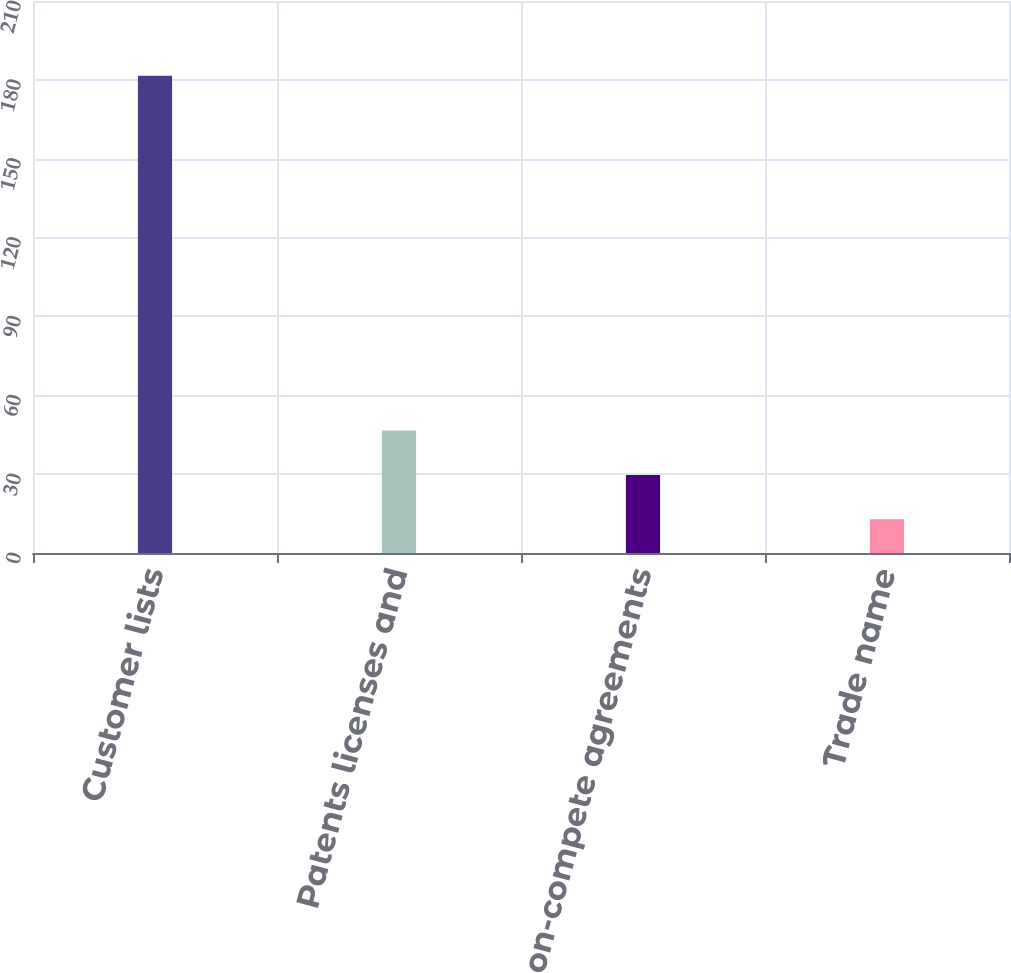Convert chart to OTSL. <chart><loc_0><loc_0><loc_500><loc_500><bar_chart><fcel>Customer lists<fcel>Patents licenses and<fcel>Non-compete agreements<fcel>Trade name<nl><fcel>181.6<fcel>46.56<fcel>29.68<fcel>12.8<nl></chart> 